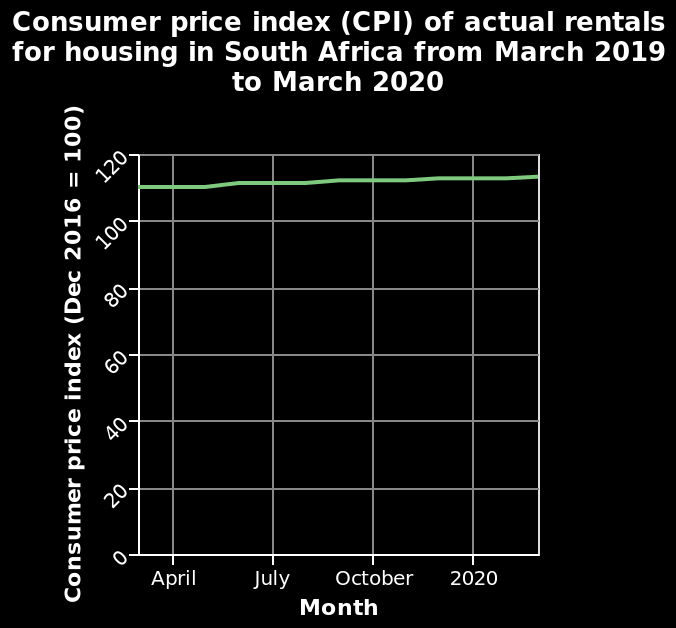<image>
Is there any noticeable variation in the consumer price index from month to month? No, there is no significant variation in the consumer price index from month to month. What is the highest value reached on the y-axis in the line diagram? The highest value reached is 120 on the Consumer price index (Dec 2016 = 100) scale. What can be concluded about the consumer price index trend over time? The consumer price index has remained relatively steady without experiencing any major fluctuations or changes. 